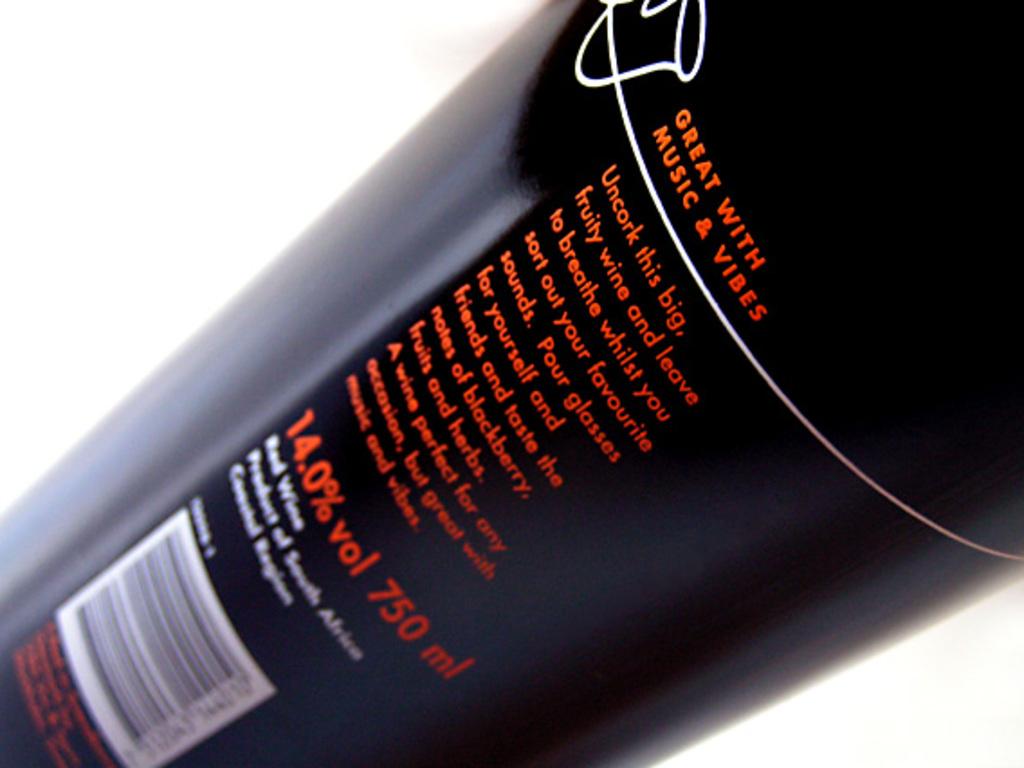What percent alcohol is this?
Make the answer very short. 14.0%. 